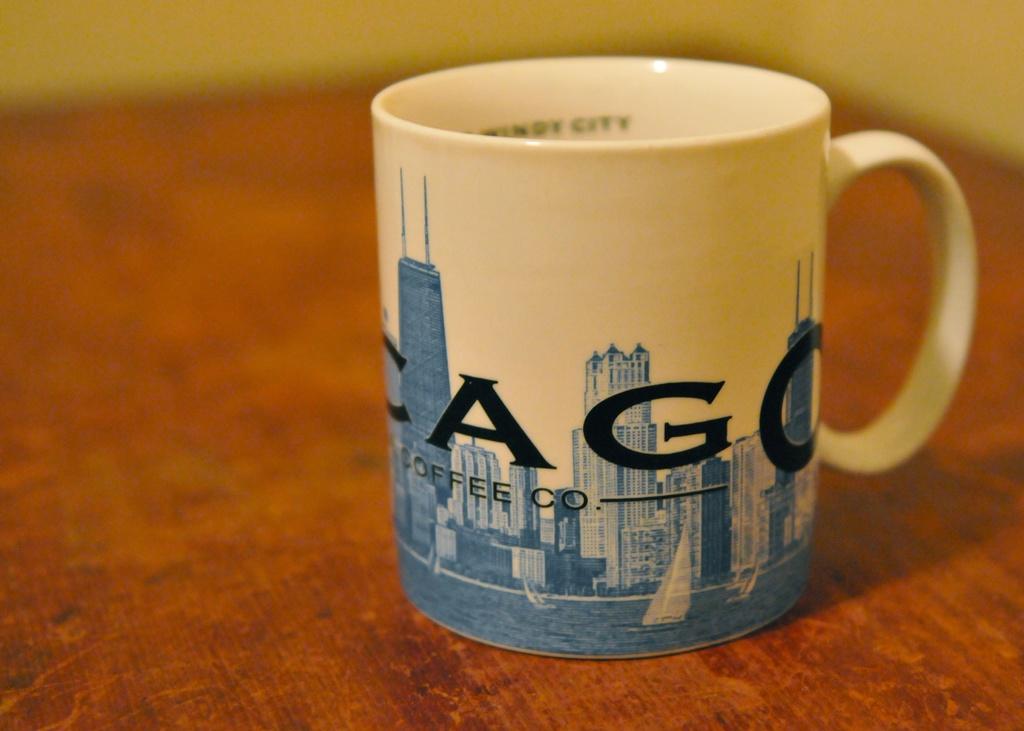What does this company make?
Your response must be concise. Coffee. What is the name of the company?
Your answer should be compact. Cago. 